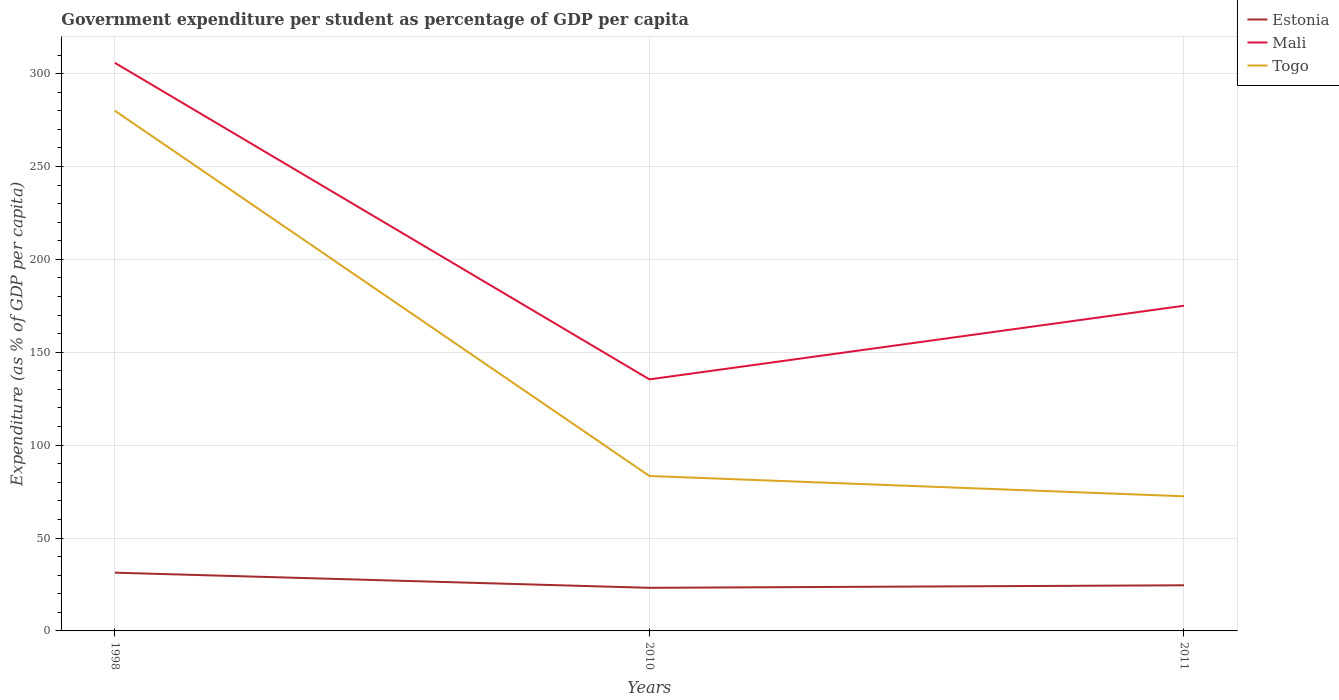How many different coloured lines are there?
Make the answer very short. 3. Across all years, what is the maximum percentage of expenditure per student in Mali?
Your answer should be very brief. 135.4. In which year was the percentage of expenditure per student in Estonia maximum?
Ensure brevity in your answer.  2010. What is the total percentage of expenditure per student in Mali in the graph?
Ensure brevity in your answer.  170.38. What is the difference between the highest and the second highest percentage of expenditure per student in Mali?
Give a very brief answer. 170.38. What is the difference between the highest and the lowest percentage of expenditure per student in Togo?
Your response must be concise. 1. How many lines are there?
Your answer should be very brief. 3. How many years are there in the graph?
Ensure brevity in your answer.  3. Does the graph contain any zero values?
Make the answer very short. No. Does the graph contain grids?
Your response must be concise. Yes. How many legend labels are there?
Give a very brief answer. 3. What is the title of the graph?
Ensure brevity in your answer.  Government expenditure per student as percentage of GDP per capita. Does "Armenia" appear as one of the legend labels in the graph?
Your answer should be compact. No. What is the label or title of the X-axis?
Keep it short and to the point. Years. What is the label or title of the Y-axis?
Give a very brief answer. Expenditure (as % of GDP per capita). What is the Expenditure (as % of GDP per capita) of Estonia in 1998?
Make the answer very short. 31.35. What is the Expenditure (as % of GDP per capita) in Mali in 1998?
Provide a succinct answer. 305.79. What is the Expenditure (as % of GDP per capita) of Togo in 1998?
Ensure brevity in your answer.  280.02. What is the Expenditure (as % of GDP per capita) in Estonia in 2010?
Keep it short and to the point. 23.2. What is the Expenditure (as % of GDP per capita) in Mali in 2010?
Your answer should be very brief. 135.4. What is the Expenditure (as % of GDP per capita) in Togo in 2010?
Make the answer very short. 83.4. What is the Expenditure (as % of GDP per capita) in Estonia in 2011?
Provide a succinct answer. 24.56. What is the Expenditure (as % of GDP per capita) of Mali in 2011?
Offer a very short reply. 175.04. What is the Expenditure (as % of GDP per capita) of Togo in 2011?
Give a very brief answer. 72.47. Across all years, what is the maximum Expenditure (as % of GDP per capita) in Estonia?
Give a very brief answer. 31.35. Across all years, what is the maximum Expenditure (as % of GDP per capita) of Mali?
Your response must be concise. 305.79. Across all years, what is the maximum Expenditure (as % of GDP per capita) in Togo?
Offer a terse response. 280.02. Across all years, what is the minimum Expenditure (as % of GDP per capita) of Estonia?
Your answer should be very brief. 23.2. Across all years, what is the minimum Expenditure (as % of GDP per capita) of Mali?
Ensure brevity in your answer.  135.4. Across all years, what is the minimum Expenditure (as % of GDP per capita) in Togo?
Make the answer very short. 72.47. What is the total Expenditure (as % of GDP per capita) in Estonia in the graph?
Provide a short and direct response. 79.12. What is the total Expenditure (as % of GDP per capita) in Mali in the graph?
Keep it short and to the point. 616.24. What is the total Expenditure (as % of GDP per capita) in Togo in the graph?
Provide a short and direct response. 435.88. What is the difference between the Expenditure (as % of GDP per capita) of Estonia in 1998 and that in 2010?
Your response must be concise. 8.15. What is the difference between the Expenditure (as % of GDP per capita) of Mali in 1998 and that in 2010?
Provide a short and direct response. 170.38. What is the difference between the Expenditure (as % of GDP per capita) in Togo in 1998 and that in 2010?
Ensure brevity in your answer.  196.62. What is the difference between the Expenditure (as % of GDP per capita) of Estonia in 1998 and that in 2011?
Your response must be concise. 6.79. What is the difference between the Expenditure (as % of GDP per capita) in Mali in 1998 and that in 2011?
Offer a terse response. 130.74. What is the difference between the Expenditure (as % of GDP per capita) of Togo in 1998 and that in 2011?
Provide a short and direct response. 207.55. What is the difference between the Expenditure (as % of GDP per capita) of Estonia in 2010 and that in 2011?
Ensure brevity in your answer.  -1.36. What is the difference between the Expenditure (as % of GDP per capita) of Mali in 2010 and that in 2011?
Make the answer very short. -39.64. What is the difference between the Expenditure (as % of GDP per capita) of Togo in 2010 and that in 2011?
Give a very brief answer. 10.93. What is the difference between the Expenditure (as % of GDP per capita) of Estonia in 1998 and the Expenditure (as % of GDP per capita) of Mali in 2010?
Give a very brief answer. -104.05. What is the difference between the Expenditure (as % of GDP per capita) of Estonia in 1998 and the Expenditure (as % of GDP per capita) of Togo in 2010?
Provide a short and direct response. -52.04. What is the difference between the Expenditure (as % of GDP per capita) in Mali in 1998 and the Expenditure (as % of GDP per capita) in Togo in 2010?
Your response must be concise. 222.39. What is the difference between the Expenditure (as % of GDP per capita) of Estonia in 1998 and the Expenditure (as % of GDP per capita) of Mali in 2011?
Provide a succinct answer. -143.69. What is the difference between the Expenditure (as % of GDP per capita) of Estonia in 1998 and the Expenditure (as % of GDP per capita) of Togo in 2011?
Your response must be concise. -41.11. What is the difference between the Expenditure (as % of GDP per capita) of Mali in 1998 and the Expenditure (as % of GDP per capita) of Togo in 2011?
Ensure brevity in your answer.  233.32. What is the difference between the Expenditure (as % of GDP per capita) in Estonia in 2010 and the Expenditure (as % of GDP per capita) in Mali in 2011?
Your answer should be compact. -151.84. What is the difference between the Expenditure (as % of GDP per capita) of Estonia in 2010 and the Expenditure (as % of GDP per capita) of Togo in 2011?
Your response must be concise. -49.26. What is the difference between the Expenditure (as % of GDP per capita) of Mali in 2010 and the Expenditure (as % of GDP per capita) of Togo in 2011?
Your response must be concise. 62.94. What is the average Expenditure (as % of GDP per capita) of Estonia per year?
Provide a short and direct response. 26.37. What is the average Expenditure (as % of GDP per capita) in Mali per year?
Provide a succinct answer. 205.41. What is the average Expenditure (as % of GDP per capita) of Togo per year?
Your response must be concise. 145.29. In the year 1998, what is the difference between the Expenditure (as % of GDP per capita) of Estonia and Expenditure (as % of GDP per capita) of Mali?
Make the answer very short. -274.43. In the year 1998, what is the difference between the Expenditure (as % of GDP per capita) of Estonia and Expenditure (as % of GDP per capita) of Togo?
Provide a succinct answer. -248.67. In the year 1998, what is the difference between the Expenditure (as % of GDP per capita) in Mali and Expenditure (as % of GDP per capita) in Togo?
Provide a short and direct response. 25.77. In the year 2010, what is the difference between the Expenditure (as % of GDP per capita) in Estonia and Expenditure (as % of GDP per capita) in Mali?
Offer a very short reply. -112.2. In the year 2010, what is the difference between the Expenditure (as % of GDP per capita) of Estonia and Expenditure (as % of GDP per capita) of Togo?
Offer a terse response. -60.19. In the year 2010, what is the difference between the Expenditure (as % of GDP per capita) in Mali and Expenditure (as % of GDP per capita) in Togo?
Make the answer very short. 52.01. In the year 2011, what is the difference between the Expenditure (as % of GDP per capita) in Estonia and Expenditure (as % of GDP per capita) in Mali?
Make the answer very short. -150.48. In the year 2011, what is the difference between the Expenditure (as % of GDP per capita) in Estonia and Expenditure (as % of GDP per capita) in Togo?
Make the answer very short. -47.9. In the year 2011, what is the difference between the Expenditure (as % of GDP per capita) of Mali and Expenditure (as % of GDP per capita) of Togo?
Offer a very short reply. 102.58. What is the ratio of the Expenditure (as % of GDP per capita) of Estonia in 1998 to that in 2010?
Offer a terse response. 1.35. What is the ratio of the Expenditure (as % of GDP per capita) in Mali in 1998 to that in 2010?
Ensure brevity in your answer.  2.26. What is the ratio of the Expenditure (as % of GDP per capita) in Togo in 1998 to that in 2010?
Your answer should be compact. 3.36. What is the ratio of the Expenditure (as % of GDP per capita) of Estonia in 1998 to that in 2011?
Make the answer very short. 1.28. What is the ratio of the Expenditure (as % of GDP per capita) in Mali in 1998 to that in 2011?
Make the answer very short. 1.75. What is the ratio of the Expenditure (as % of GDP per capita) of Togo in 1998 to that in 2011?
Keep it short and to the point. 3.86. What is the ratio of the Expenditure (as % of GDP per capita) in Estonia in 2010 to that in 2011?
Give a very brief answer. 0.94. What is the ratio of the Expenditure (as % of GDP per capita) in Mali in 2010 to that in 2011?
Ensure brevity in your answer.  0.77. What is the ratio of the Expenditure (as % of GDP per capita) in Togo in 2010 to that in 2011?
Give a very brief answer. 1.15. What is the difference between the highest and the second highest Expenditure (as % of GDP per capita) in Estonia?
Offer a terse response. 6.79. What is the difference between the highest and the second highest Expenditure (as % of GDP per capita) of Mali?
Give a very brief answer. 130.74. What is the difference between the highest and the second highest Expenditure (as % of GDP per capita) in Togo?
Provide a short and direct response. 196.62. What is the difference between the highest and the lowest Expenditure (as % of GDP per capita) of Estonia?
Offer a terse response. 8.15. What is the difference between the highest and the lowest Expenditure (as % of GDP per capita) of Mali?
Give a very brief answer. 170.38. What is the difference between the highest and the lowest Expenditure (as % of GDP per capita) of Togo?
Make the answer very short. 207.55. 